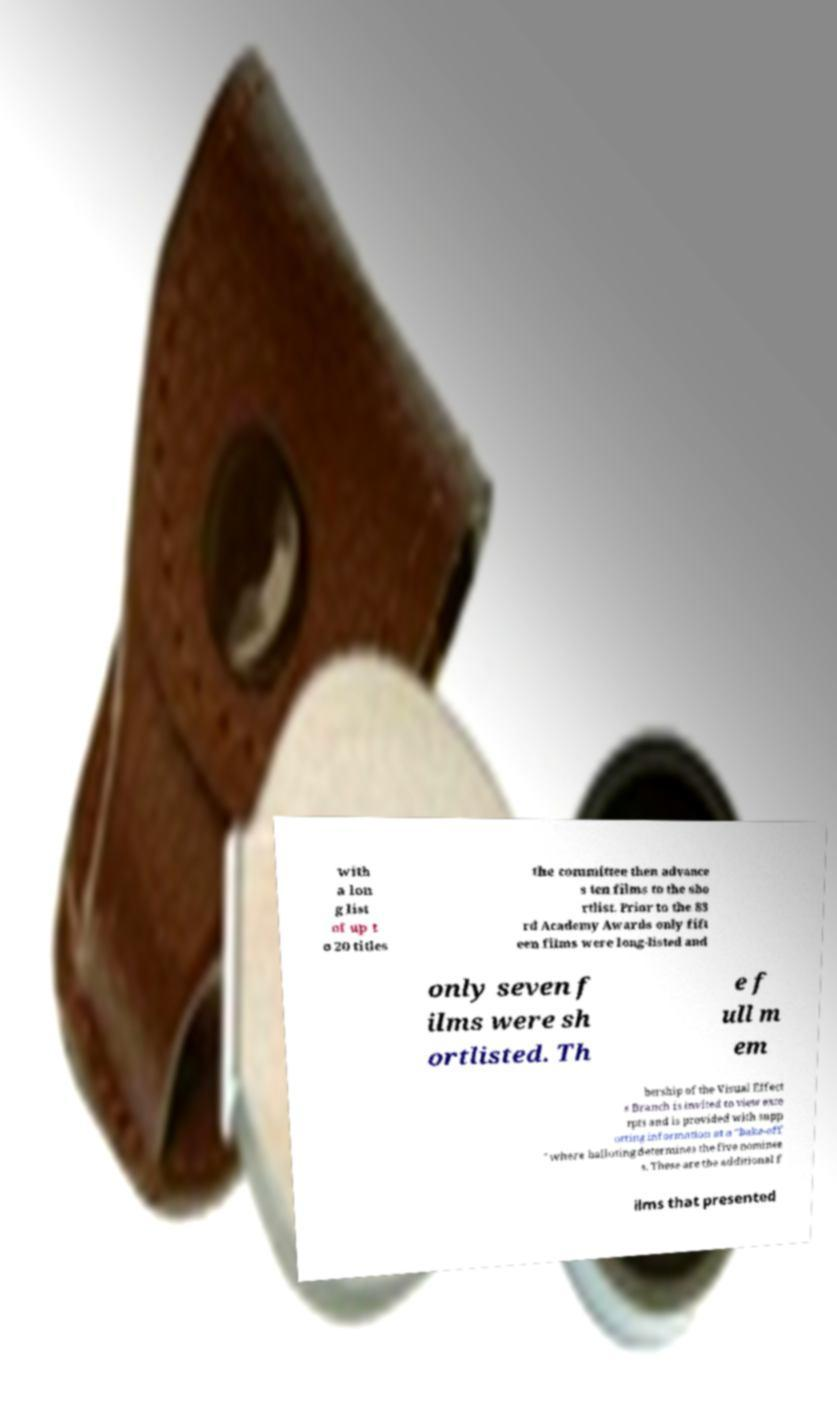Can you read and provide the text displayed in the image?This photo seems to have some interesting text. Can you extract and type it out for me? with a lon g list of up t o 20 titles the committee then advance s ten films to the sho rtlist. Prior to the 83 rd Academy Awards only fift een films were long-listed and only seven f ilms were sh ortlisted. Th e f ull m em bership of the Visual Effect s Branch is invited to view exce rpts and is provided with supp orting information at a "bake-off " where balloting determines the five nominee s. These are the additional f ilms that presented 